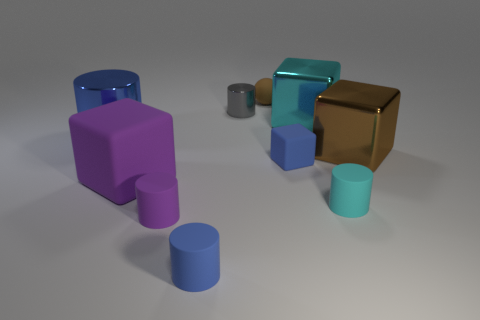There is a large object that is the same color as the small block; what is its material?
Your answer should be very brief. Metal. Do the large metallic cylinder and the small block have the same color?
Provide a succinct answer. Yes. There is a brown thing to the left of the tiny cyan cylinder; what is it made of?
Provide a short and direct response. Rubber. What is the material of the blue cylinder right of the shiny cylinder that is in front of the cyan thing that is behind the big brown metallic cube?
Your answer should be compact. Rubber. How many other objects are the same color as the big cylinder?
Ensure brevity in your answer.  2. Does the big block that is to the right of the cyan rubber cylinder have the same color as the matte ball?
Provide a short and direct response. Yes. Is the material of the large thing right of the small cyan matte thing the same as the purple cylinder?
Ensure brevity in your answer.  No. There is a tiny object in front of the tiny purple object; is it the same shape as the big blue shiny object?
Provide a short and direct response. Yes. There is a shiny object in front of the blue metal object; are there any big purple cubes that are behind it?
Offer a very short reply. No. How many small cyan rubber objects are there?
Keep it short and to the point. 1. 